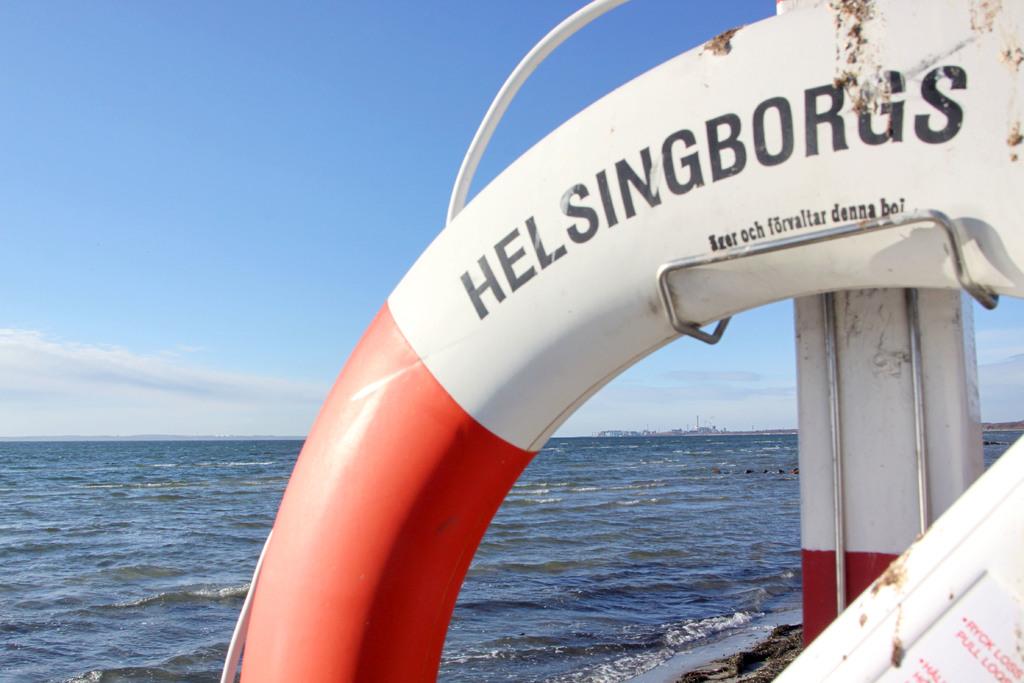What does the life preserve say?
Keep it short and to the point. Helsingborgs. 